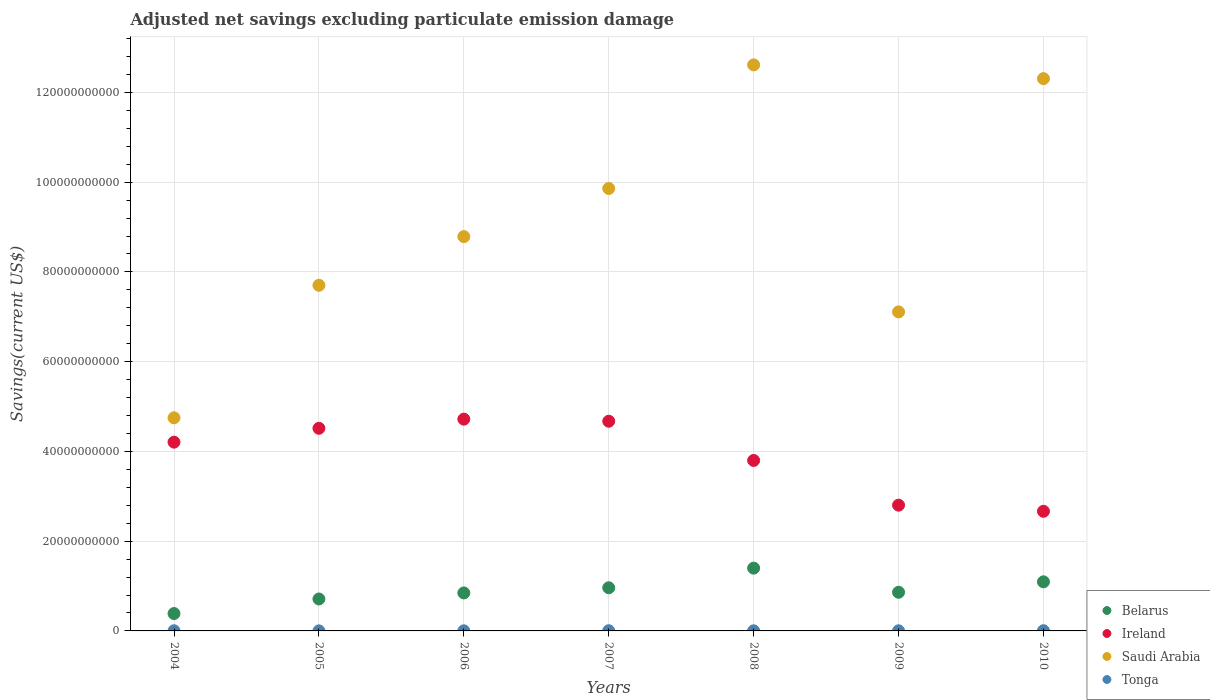What is the adjusted net savings in Saudi Arabia in 2007?
Your response must be concise. 9.86e+1. Across all years, what is the maximum adjusted net savings in Saudi Arabia?
Offer a very short reply. 1.26e+11. Across all years, what is the minimum adjusted net savings in Ireland?
Keep it short and to the point. 2.67e+1. What is the total adjusted net savings in Tonga in the graph?
Your answer should be very brief. 2.22e+08. What is the difference between the adjusted net savings in Belarus in 2008 and that in 2009?
Keep it short and to the point. 5.38e+09. What is the difference between the adjusted net savings in Ireland in 2006 and the adjusted net savings in Tonga in 2009?
Your answer should be compact. 4.72e+1. What is the average adjusted net savings in Saudi Arabia per year?
Offer a very short reply. 9.02e+1. In the year 2010, what is the difference between the adjusted net savings in Belarus and adjusted net savings in Ireland?
Offer a very short reply. -1.57e+1. What is the ratio of the adjusted net savings in Ireland in 2005 to that in 2009?
Ensure brevity in your answer.  1.61. Is the difference between the adjusted net savings in Belarus in 2006 and 2009 greater than the difference between the adjusted net savings in Ireland in 2006 and 2009?
Keep it short and to the point. No. What is the difference between the highest and the second highest adjusted net savings in Ireland?
Ensure brevity in your answer.  4.67e+08. What is the difference between the highest and the lowest adjusted net savings in Tonga?
Give a very brief answer. 3.14e+07. In how many years, is the adjusted net savings in Belarus greater than the average adjusted net savings in Belarus taken over all years?
Your response must be concise. 3. Is the sum of the adjusted net savings in Tonga in 2006 and 2007 greater than the maximum adjusted net savings in Belarus across all years?
Offer a very short reply. No. Is the adjusted net savings in Tonga strictly less than the adjusted net savings in Saudi Arabia over the years?
Make the answer very short. Yes. How many years are there in the graph?
Your response must be concise. 7. What is the difference between two consecutive major ticks on the Y-axis?
Your answer should be very brief. 2.00e+1. Does the graph contain any zero values?
Your answer should be very brief. No. Does the graph contain grids?
Offer a terse response. Yes. How many legend labels are there?
Your answer should be compact. 4. How are the legend labels stacked?
Make the answer very short. Vertical. What is the title of the graph?
Your answer should be compact. Adjusted net savings excluding particulate emission damage. Does "Malaysia" appear as one of the legend labels in the graph?
Provide a short and direct response. No. What is the label or title of the X-axis?
Give a very brief answer. Years. What is the label or title of the Y-axis?
Make the answer very short. Savings(current US$). What is the Savings(current US$) of Belarus in 2004?
Offer a very short reply. 3.87e+09. What is the Savings(current US$) in Ireland in 2004?
Offer a terse response. 4.21e+1. What is the Savings(current US$) of Saudi Arabia in 2004?
Give a very brief answer. 4.75e+1. What is the Savings(current US$) of Tonga in 2004?
Give a very brief answer. 3.54e+07. What is the Savings(current US$) of Belarus in 2005?
Keep it short and to the point. 7.12e+09. What is the Savings(current US$) of Ireland in 2005?
Provide a short and direct response. 4.52e+1. What is the Savings(current US$) in Saudi Arabia in 2005?
Offer a very short reply. 7.70e+1. What is the Savings(current US$) of Tonga in 2005?
Ensure brevity in your answer.  1.44e+07. What is the Savings(current US$) of Belarus in 2006?
Make the answer very short. 8.46e+09. What is the Savings(current US$) in Ireland in 2006?
Your answer should be compact. 4.72e+1. What is the Savings(current US$) in Saudi Arabia in 2006?
Offer a terse response. 8.79e+1. What is the Savings(current US$) in Tonga in 2006?
Offer a very short reply. 2.58e+07. What is the Savings(current US$) of Belarus in 2007?
Provide a short and direct response. 9.62e+09. What is the Savings(current US$) of Ireland in 2007?
Provide a succinct answer. 4.67e+1. What is the Savings(current US$) of Saudi Arabia in 2007?
Ensure brevity in your answer.  9.86e+1. What is the Savings(current US$) of Tonga in 2007?
Give a very brief answer. 4.41e+07. What is the Savings(current US$) of Belarus in 2008?
Provide a short and direct response. 1.40e+1. What is the Savings(current US$) in Ireland in 2008?
Give a very brief answer. 3.80e+1. What is the Savings(current US$) of Saudi Arabia in 2008?
Offer a terse response. 1.26e+11. What is the Savings(current US$) of Tonga in 2008?
Keep it short and to the point. 2.59e+07. What is the Savings(current US$) in Belarus in 2009?
Your response must be concise. 8.61e+09. What is the Savings(current US$) in Ireland in 2009?
Provide a short and direct response. 2.80e+1. What is the Savings(current US$) of Saudi Arabia in 2009?
Keep it short and to the point. 7.11e+1. What is the Savings(current US$) of Tonga in 2009?
Your answer should be very brief. 3.08e+07. What is the Savings(current US$) in Belarus in 2010?
Your answer should be compact. 1.09e+1. What is the Savings(current US$) of Ireland in 2010?
Ensure brevity in your answer.  2.67e+1. What is the Savings(current US$) in Saudi Arabia in 2010?
Ensure brevity in your answer.  1.23e+11. What is the Savings(current US$) of Tonga in 2010?
Offer a terse response. 4.58e+07. Across all years, what is the maximum Savings(current US$) of Belarus?
Give a very brief answer. 1.40e+1. Across all years, what is the maximum Savings(current US$) in Ireland?
Provide a succinct answer. 4.72e+1. Across all years, what is the maximum Savings(current US$) in Saudi Arabia?
Provide a short and direct response. 1.26e+11. Across all years, what is the maximum Savings(current US$) in Tonga?
Give a very brief answer. 4.58e+07. Across all years, what is the minimum Savings(current US$) in Belarus?
Offer a very short reply. 3.87e+09. Across all years, what is the minimum Savings(current US$) of Ireland?
Ensure brevity in your answer.  2.67e+1. Across all years, what is the minimum Savings(current US$) in Saudi Arabia?
Your answer should be very brief. 4.75e+1. Across all years, what is the minimum Savings(current US$) in Tonga?
Your response must be concise. 1.44e+07. What is the total Savings(current US$) of Belarus in the graph?
Ensure brevity in your answer.  6.26e+1. What is the total Savings(current US$) of Ireland in the graph?
Your answer should be very brief. 2.74e+11. What is the total Savings(current US$) of Saudi Arabia in the graph?
Offer a very short reply. 6.31e+11. What is the total Savings(current US$) in Tonga in the graph?
Your answer should be compact. 2.22e+08. What is the difference between the Savings(current US$) in Belarus in 2004 and that in 2005?
Provide a succinct answer. -3.24e+09. What is the difference between the Savings(current US$) of Ireland in 2004 and that in 2005?
Offer a terse response. -3.09e+09. What is the difference between the Savings(current US$) in Saudi Arabia in 2004 and that in 2005?
Offer a terse response. -2.95e+1. What is the difference between the Savings(current US$) of Tonga in 2004 and that in 2005?
Keep it short and to the point. 2.10e+07. What is the difference between the Savings(current US$) of Belarus in 2004 and that in 2006?
Give a very brief answer. -4.59e+09. What is the difference between the Savings(current US$) in Ireland in 2004 and that in 2006?
Your answer should be compact. -5.13e+09. What is the difference between the Savings(current US$) of Saudi Arabia in 2004 and that in 2006?
Your answer should be very brief. -4.04e+1. What is the difference between the Savings(current US$) of Tonga in 2004 and that in 2006?
Your response must be concise. 9.57e+06. What is the difference between the Savings(current US$) of Belarus in 2004 and that in 2007?
Offer a terse response. -5.74e+09. What is the difference between the Savings(current US$) in Ireland in 2004 and that in 2007?
Your response must be concise. -4.66e+09. What is the difference between the Savings(current US$) of Saudi Arabia in 2004 and that in 2007?
Keep it short and to the point. -5.11e+1. What is the difference between the Savings(current US$) of Tonga in 2004 and that in 2007?
Keep it short and to the point. -8.75e+06. What is the difference between the Savings(current US$) in Belarus in 2004 and that in 2008?
Your answer should be very brief. -1.01e+1. What is the difference between the Savings(current US$) of Ireland in 2004 and that in 2008?
Keep it short and to the point. 4.07e+09. What is the difference between the Savings(current US$) of Saudi Arabia in 2004 and that in 2008?
Your answer should be compact. -7.86e+1. What is the difference between the Savings(current US$) of Tonga in 2004 and that in 2008?
Make the answer very short. 9.45e+06. What is the difference between the Savings(current US$) in Belarus in 2004 and that in 2009?
Offer a terse response. -4.74e+09. What is the difference between the Savings(current US$) in Ireland in 2004 and that in 2009?
Your answer should be compact. 1.40e+1. What is the difference between the Savings(current US$) in Saudi Arabia in 2004 and that in 2009?
Ensure brevity in your answer.  -2.36e+1. What is the difference between the Savings(current US$) of Tonga in 2004 and that in 2009?
Provide a succinct answer. 4.51e+06. What is the difference between the Savings(current US$) in Belarus in 2004 and that in 2010?
Make the answer very short. -7.07e+09. What is the difference between the Savings(current US$) of Ireland in 2004 and that in 2010?
Make the answer very short. 1.54e+1. What is the difference between the Savings(current US$) in Saudi Arabia in 2004 and that in 2010?
Your answer should be compact. -7.56e+1. What is the difference between the Savings(current US$) in Tonga in 2004 and that in 2010?
Make the answer very short. -1.04e+07. What is the difference between the Savings(current US$) of Belarus in 2005 and that in 2006?
Keep it short and to the point. -1.35e+09. What is the difference between the Savings(current US$) in Ireland in 2005 and that in 2006?
Your answer should be compact. -2.04e+09. What is the difference between the Savings(current US$) of Saudi Arabia in 2005 and that in 2006?
Offer a very short reply. -1.08e+1. What is the difference between the Savings(current US$) of Tonga in 2005 and that in 2006?
Provide a succinct answer. -1.14e+07. What is the difference between the Savings(current US$) in Belarus in 2005 and that in 2007?
Ensure brevity in your answer.  -2.50e+09. What is the difference between the Savings(current US$) of Ireland in 2005 and that in 2007?
Keep it short and to the point. -1.57e+09. What is the difference between the Savings(current US$) in Saudi Arabia in 2005 and that in 2007?
Offer a terse response. -2.16e+1. What is the difference between the Savings(current US$) of Tonga in 2005 and that in 2007?
Keep it short and to the point. -2.97e+07. What is the difference between the Savings(current US$) of Belarus in 2005 and that in 2008?
Your answer should be compact. -6.87e+09. What is the difference between the Savings(current US$) of Ireland in 2005 and that in 2008?
Your answer should be compact. 7.16e+09. What is the difference between the Savings(current US$) in Saudi Arabia in 2005 and that in 2008?
Provide a short and direct response. -4.91e+1. What is the difference between the Savings(current US$) of Tonga in 2005 and that in 2008?
Make the answer very short. -1.15e+07. What is the difference between the Savings(current US$) of Belarus in 2005 and that in 2009?
Your answer should be very brief. -1.50e+09. What is the difference between the Savings(current US$) in Ireland in 2005 and that in 2009?
Provide a short and direct response. 1.71e+1. What is the difference between the Savings(current US$) of Saudi Arabia in 2005 and that in 2009?
Offer a terse response. 5.93e+09. What is the difference between the Savings(current US$) in Tonga in 2005 and that in 2009?
Make the answer very short. -1.65e+07. What is the difference between the Savings(current US$) in Belarus in 2005 and that in 2010?
Give a very brief answer. -3.82e+09. What is the difference between the Savings(current US$) of Ireland in 2005 and that in 2010?
Your answer should be very brief. 1.85e+1. What is the difference between the Savings(current US$) of Saudi Arabia in 2005 and that in 2010?
Give a very brief answer. -4.61e+1. What is the difference between the Savings(current US$) in Tonga in 2005 and that in 2010?
Your response must be concise. -3.14e+07. What is the difference between the Savings(current US$) in Belarus in 2006 and that in 2007?
Your response must be concise. -1.15e+09. What is the difference between the Savings(current US$) in Ireland in 2006 and that in 2007?
Your answer should be compact. 4.67e+08. What is the difference between the Savings(current US$) of Saudi Arabia in 2006 and that in 2007?
Your answer should be compact. -1.07e+1. What is the difference between the Savings(current US$) of Tonga in 2006 and that in 2007?
Your answer should be compact. -1.83e+07. What is the difference between the Savings(current US$) in Belarus in 2006 and that in 2008?
Your response must be concise. -5.53e+09. What is the difference between the Savings(current US$) in Ireland in 2006 and that in 2008?
Offer a very short reply. 9.20e+09. What is the difference between the Savings(current US$) of Saudi Arabia in 2006 and that in 2008?
Ensure brevity in your answer.  -3.83e+1. What is the difference between the Savings(current US$) of Tonga in 2006 and that in 2008?
Offer a very short reply. -1.22e+05. What is the difference between the Savings(current US$) in Belarus in 2006 and that in 2009?
Offer a terse response. -1.50e+08. What is the difference between the Savings(current US$) of Ireland in 2006 and that in 2009?
Ensure brevity in your answer.  1.92e+1. What is the difference between the Savings(current US$) of Saudi Arabia in 2006 and that in 2009?
Provide a short and direct response. 1.68e+1. What is the difference between the Savings(current US$) in Tonga in 2006 and that in 2009?
Ensure brevity in your answer.  -5.06e+06. What is the difference between the Savings(current US$) in Belarus in 2006 and that in 2010?
Your response must be concise. -2.48e+09. What is the difference between the Savings(current US$) in Ireland in 2006 and that in 2010?
Provide a succinct answer. 2.05e+1. What is the difference between the Savings(current US$) of Saudi Arabia in 2006 and that in 2010?
Your answer should be compact. -3.52e+1. What is the difference between the Savings(current US$) of Tonga in 2006 and that in 2010?
Make the answer very short. -2.00e+07. What is the difference between the Savings(current US$) of Belarus in 2007 and that in 2008?
Provide a succinct answer. -4.37e+09. What is the difference between the Savings(current US$) of Ireland in 2007 and that in 2008?
Your answer should be compact. 8.74e+09. What is the difference between the Savings(current US$) in Saudi Arabia in 2007 and that in 2008?
Your answer should be very brief. -2.75e+1. What is the difference between the Savings(current US$) of Tonga in 2007 and that in 2008?
Provide a short and direct response. 1.82e+07. What is the difference between the Savings(current US$) of Belarus in 2007 and that in 2009?
Provide a succinct answer. 1.00e+09. What is the difference between the Savings(current US$) in Ireland in 2007 and that in 2009?
Your response must be concise. 1.87e+1. What is the difference between the Savings(current US$) of Saudi Arabia in 2007 and that in 2009?
Offer a terse response. 2.75e+1. What is the difference between the Savings(current US$) in Tonga in 2007 and that in 2009?
Offer a terse response. 1.33e+07. What is the difference between the Savings(current US$) in Belarus in 2007 and that in 2010?
Give a very brief answer. -1.32e+09. What is the difference between the Savings(current US$) of Ireland in 2007 and that in 2010?
Offer a very short reply. 2.01e+1. What is the difference between the Savings(current US$) of Saudi Arabia in 2007 and that in 2010?
Offer a very short reply. -2.45e+1. What is the difference between the Savings(current US$) in Tonga in 2007 and that in 2010?
Give a very brief answer. -1.69e+06. What is the difference between the Savings(current US$) of Belarus in 2008 and that in 2009?
Ensure brevity in your answer.  5.38e+09. What is the difference between the Savings(current US$) of Ireland in 2008 and that in 2009?
Offer a very short reply. 9.96e+09. What is the difference between the Savings(current US$) in Saudi Arabia in 2008 and that in 2009?
Offer a very short reply. 5.50e+1. What is the difference between the Savings(current US$) in Tonga in 2008 and that in 2009?
Give a very brief answer. -4.94e+06. What is the difference between the Savings(current US$) in Belarus in 2008 and that in 2010?
Keep it short and to the point. 3.05e+09. What is the difference between the Savings(current US$) of Ireland in 2008 and that in 2010?
Your response must be concise. 1.13e+1. What is the difference between the Savings(current US$) of Saudi Arabia in 2008 and that in 2010?
Offer a terse response. 3.06e+09. What is the difference between the Savings(current US$) in Tonga in 2008 and that in 2010?
Offer a terse response. -1.99e+07. What is the difference between the Savings(current US$) in Belarus in 2009 and that in 2010?
Make the answer very short. -2.33e+09. What is the difference between the Savings(current US$) in Ireland in 2009 and that in 2010?
Provide a short and direct response. 1.36e+09. What is the difference between the Savings(current US$) in Saudi Arabia in 2009 and that in 2010?
Your response must be concise. -5.20e+1. What is the difference between the Savings(current US$) in Tonga in 2009 and that in 2010?
Give a very brief answer. -1.49e+07. What is the difference between the Savings(current US$) of Belarus in 2004 and the Savings(current US$) of Ireland in 2005?
Offer a very short reply. -4.13e+1. What is the difference between the Savings(current US$) of Belarus in 2004 and the Savings(current US$) of Saudi Arabia in 2005?
Give a very brief answer. -7.31e+1. What is the difference between the Savings(current US$) of Belarus in 2004 and the Savings(current US$) of Tonga in 2005?
Make the answer very short. 3.86e+09. What is the difference between the Savings(current US$) of Ireland in 2004 and the Savings(current US$) of Saudi Arabia in 2005?
Make the answer very short. -3.50e+1. What is the difference between the Savings(current US$) in Ireland in 2004 and the Savings(current US$) in Tonga in 2005?
Provide a short and direct response. 4.20e+1. What is the difference between the Savings(current US$) of Saudi Arabia in 2004 and the Savings(current US$) of Tonga in 2005?
Make the answer very short. 4.75e+1. What is the difference between the Savings(current US$) in Belarus in 2004 and the Savings(current US$) in Ireland in 2006?
Give a very brief answer. -4.33e+1. What is the difference between the Savings(current US$) of Belarus in 2004 and the Savings(current US$) of Saudi Arabia in 2006?
Offer a very short reply. -8.40e+1. What is the difference between the Savings(current US$) in Belarus in 2004 and the Savings(current US$) in Tonga in 2006?
Offer a terse response. 3.85e+09. What is the difference between the Savings(current US$) in Ireland in 2004 and the Savings(current US$) in Saudi Arabia in 2006?
Give a very brief answer. -4.58e+1. What is the difference between the Savings(current US$) of Ireland in 2004 and the Savings(current US$) of Tonga in 2006?
Keep it short and to the point. 4.20e+1. What is the difference between the Savings(current US$) of Saudi Arabia in 2004 and the Savings(current US$) of Tonga in 2006?
Your response must be concise. 4.75e+1. What is the difference between the Savings(current US$) of Belarus in 2004 and the Savings(current US$) of Ireland in 2007?
Your answer should be compact. -4.28e+1. What is the difference between the Savings(current US$) in Belarus in 2004 and the Savings(current US$) in Saudi Arabia in 2007?
Your answer should be compact. -9.47e+1. What is the difference between the Savings(current US$) of Belarus in 2004 and the Savings(current US$) of Tonga in 2007?
Give a very brief answer. 3.83e+09. What is the difference between the Savings(current US$) of Ireland in 2004 and the Savings(current US$) of Saudi Arabia in 2007?
Your response must be concise. -5.65e+1. What is the difference between the Savings(current US$) of Ireland in 2004 and the Savings(current US$) of Tonga in 2007?
Offer a terse response. 4.20e+1. What is the difference between the Savings(current US$) in Saudi Arabia in 2004 and the Savings(current US$) in Tonga in 2007?
Make the answer very short. 4.74e+1. What is the difference between the Savings(current US$) in Belarus in 2004 and the Savings(current US$) in Ireland in 2008?
Make the answer very short. -3.41e+1. What is the difference between the Savings(current US$) of Belarus in 2004 and the Savings(current US$) of Saudi Arabia in 2008?
Your response must be concise. -1.22e+11. What is the difference between the Savings(current US$) in Belarus in 2004 and the Savings(current US$) in Tonga in 2008?
Offer a terse response. 3.85e+09. What is the difference between the Savings(current US$) in Ireland in 2004 and the Savings(current US$) in Saudi Arabia in 2008?
Keep it short and to the point. -8.41e+1. What is the difference between the Savings(current US$) of Ireland in 2004 and the Savings(current US$) of Tonga in 2008?
Ensure brevity in your answer.  4.20e+1. What is the difference between the Savings(current US$) of Saudi Arabia in 2004 and the Savings(current US$) of Tonga in 2008?
Ensure brevity in your answer.  4.75e+1. What is the difference between the Savings(current US$) of Belarus in 2004 and the Savings(current US$) of Ireland in 2009?
Provide a succinct answer. -2.41e+1. What is the difference between the Savings(current US$) of Belarus in 2004 and the Savings(current US$) of Saudi Arabia in 2009?
Offer a very short reply. -6.72e+1. What is the difference between the Savings(current US$) of Belarus in 2004 and the Savings(current US$) of Tonga in 2009?
Make the answer very short. 3.84e+09. What is the difference between the Savings(current US$) in Ireland in 2004 and the Savings(current US$) in Saudi Arabia in 2009?
Give a very brief answer. -2.90e+1. What is the difference between the Savings(current US$) in Ireland in 2004 and the Savings(current US$) in Tonga in 2009?
Give a very brief answer. 4.20e+1. What is the difference between the Savings(current US$) in Saudi Arabia in 2004 and the Savings(current US$) in Tonga in 2009?
Make the answer very short. 4.75e+1. What is the difference between the Savings(current US$) of Belarus in 2004 and the Savings(current US$) of Ireland in 2010?
Ensure brevity in your answer.  -2.28e+1. What is the difference between the Savings(current US$) in Belarus in 2004 and the Savings(current US$) in Saudi Arabia in 2010?
Your answer should be compact. -1.19e+11. What is the difference between the Savings(current US$) of Belarus in 2004 and the Savings(current US$) of Tonga in 2010?
Provide a short and direct response. 3.83e+09. What is the difference between the Savings(current US$) in Ireland in 2004 and the Savings(current US$) in Saudi Arabia in 2010?
Keep it short and to the point. -8.10e+1. What is the difference between the Savings(current US$) of Ireland in 2004 and the Savings(current US$) of Tonga in 2010?
Offer a very short reply. 4.20e+1. What is the difference between the Savings(current US$) in Saudi Arabia in 2004 and the Savings(current US$) in Tonga in 2010?
Offer a terse response. 4.74e+1. What is the difference between the Savings(current US$) in Belarus in 2005 and the Savings(current US$) in Ireland in 2006?
Ensure brevity in your answer.  -4.01e+1. What is the difference between the Savings(current US$) of Belarus in 2005 and the Savings(current US$) of Saudi Arabia in 2006?
Offer a terse response. -8.07e+1. What is the difference between the Savings(current US$) of Belarus in 2005 and the Savings(current US$) of Tonga in 2006?
Ensure brevity in your answer.  7.09e+09. What is the difference between the Savings(current US$) in Ireland in 2005 and the Savings(current US$) in Saudi Arabia in 2006?
Your answer should be very brief. -4.27e+1. What is the difference between the Savings(current US$) in Ireland in 2005 and the Savings(current US$) in Tonga in 2006?
Offer a very short reply. 4.51e+1. What is the difference between the Savings(current US$) in Saudi Arabia in 2005 and the Savings(current US$) in Tonga in 2006?
Provide a short and direct response. 7.70e+1. What is the difference between the Savings(current US$) of Belarus in 2005 and the Savings(current US$) of Ireland in 2007?
Provide a succinct answer. -3.96e+1. What is the difference between the Savings(current US$) in Belarus in 2005 and the Savings(current US$) in Saudi Arabia in 2007?
Ensure brevity in your answer.  -9.15e+1. What is the difference between the Savings(current US$) of Belarus in 2005 and the Savings(current US$) of Tonga in 2007?
Make the answer very short. 7.07e+09. What is the difference between the Savings(current US$) of Ireland in 2005 and the Savings(current US$) of Saudi Arabia in 2007?
Your answer should be very brief. -5.34e+1. What is the difference between the Savings(current US$) in Ireland in 2005 and the Savings(current US$) in Tonga in 2007?
Provide a succinct answer. 4.51e+1. What is the difference between the Savings(current US$) in Saudi Arabia in 2005 and the Savings(current US$) in Tonga in 2007?
Your answer should be very brief. 7.70e+1. What is the difference between the Savings(current US$) of Belarus in 2005 and the Savings(current US$) of Ireland in 2008?
Make the answer very short. -3.09e+1. What is the difference between the Savings(current US$) of Belarus in 2005 and the Savings(current US$) of Saudi Arabia in 2008?
Provide a short and direct response. -1.19e+11. What is the difference between the Savings(current US$) of Belarus in 2005 and the Savings(current US$) of Tonga in 2008?
Make the answer very short. 7.09e+09. What is the difference between the Savings(current US$) in Ireland in 2005 and the Savings(current US$) in Saudi Arabia in 2008?
Your answer should be very brief. -8.10e+1. What is the difference between the Savings(current US$) of Ireland in 2005 and the Savings(current US$) of Tonga in 2008?
Your answer should be very brief. 4.51e+1. What is the difference between the Savings(current US$) in Saudi Arabia in 2005 and the Savings(current US$) in Tonga in 2008?
Ensure brevity in your answer.  7.70e+1. What is the difference between the Savings(current US$) of Belarus in 2005 and the Savings(current US$) of Ireland in 2009?
Give a very brief answer. -2.09e+1. What is the difference between the Savings(current US$) of Belarus in 2005 and the Savings(current US$) of Saudi Arabia in 2009?
Offer a terse response. -6.40e+1. What is the difference between the Savings(current US$) of Belarus in 2005 and the Savings(current US$) of Tonga in 2009?
Offer a terse response. 7.09e+09. What is the difference between the Savings(current US$) in Ireland in 2005 and the Savings(current US$) in Saudi Arabia in 2009?
Your answer should be compact. -2.59e+1. What is the difference between the Savings(current US$) in Ireland in 2005 and the Savings(current US$) in Tonga in 2009?
Your answer should be very brief. 4.51e+1. What is the difference between the Savings(current US$) in Saudi Arabia in 2005 and the Savings(current US$) in Tonga in 2009?
Your answer should be very brief. 7.70e+1. What is the difference between the Savings(current US$) of Belarus in 2005 and the Savings(current US$) of Ireland in 2010?
Offer a very short reply. -1.95e+1. What is the difference between the Savings(current US$) in Belarus in 2005 and the Savings(current US$) in Saudi Arabia in 2010?
Your response must be concise. -1.16e+11. What is the difference between the Savings(current US$) in Belarus in 2005 and the Savings(current US$) in Tonga in 2010?
Provide a succinct answer. 7.07e+09. What is the difference between the Savings(current US$) in Ireland in 2005 and the Savings(current US$) in Saudi Arabia in 2010?
Your answer should be very brief. -7.79e+1. What is the difference between the Savings(current US$) in Ireland in 2005 and the Savings(current US$) in Tonga in 2010?
Offer a terse response. 4.51e+1. What is the difference between the Savings(current US$) of Saudi Arabia in 2005 and the Savings(current US$) of Tonga in 2010?
Give a very brief answer. 7.70e+1. What is the difference between the Savings(current US$) in Belarus in 2006 and the Savings(current US$) in Ireland in 2007?
Your response must be concise. -3.83e+1. What is the difference between the Savings(current US$) of Belarus in 2006 and the Savings(current US$) of Saudi Arabia in 2007?
Give a very brief answer. -9.01e+1. What is the difference between the Savings(current US$) in Belarus in 2006 and the Savings(current US$) in Tonga in 2007?
Give a very brief answer. 8.42e+09. What is the difference between the Savings(current US$) in Ireland in 2006 and the Savings(current US$) in Saudi Arabia in 2007?
Make the answer very short. -5.14e+1. What is the difference between the Savings(current US$) of Ireland in 2006 and the Savings(current US$) of Tonga in 2007?
Keep it short and to the point. 4.71e+1. What is the difference between the Savings(current US$) in Saudi Arabia in 2006 and the Savings(current US$) in Tonga in 2007?
Offer a terse response. 8.78e+1. What is the difference between the Savings(current US$) of Belarus in 2006 and the Savings(current US$) of Ireland in 2008?
Give a very brief answer. -2.95e+1. What is the difference between the Savings(current US$) of Belarus in 2006 and the Savings(current US$) of Saudi Arabia in 2008?
Your answer should be very brief. -1.18e+11. What is the difference between the Savings(current US$) in Belarus in 2006 and the Savings(current US$) in Tonga in 2008?
Make the answer very short. 8.44e+09. What is the difference between the Savings(current US$) in Ireland in 2006 and the Savings(current US$) in Saudi Arabia in 2008?
Make the answer very short. -7.89e+1. What is the difference between the Savings(current US$) in Ireland in 2006 and the Savings(current US$) in Tonga in 2008?
Provide a short and direct response. 4.72e+1. What is the difference between the Savings(current US$) of Saudi Arabia in 2006 and the Savings(current US$) of Tonga in 2008?
Provide a succinct answer. 8.78e+1. What is the difference between the Savings(current US$) of Belarus in 2006 and the Savings(current US$) of Ireland in 2009?
Offer a very short reply. -1.96e+1. What is the difference between the Savings(current US$) in Belarus in 2006 and the Savings(current US$) in Saudi Arabia in 2009?
Make the answer very short. -6.26e+1. What is the difference between the Savings(current US$) in Belarus in 2006 and the Savings(current US$) in Tonga in 2009?
Ensure brevity in your answer.  8.43e+09. What is the difference between the Savings(current US$) in Ireland in 2006 and the Savings(current US$) in Saudi Arabia in 2009?
Offer a terse response. -2.39e+1. What is the difference between the Savings(current US$) in Ireland in 2006 and the Savings(current US$) in Tonga in 2009?
Give a very brief answer. 4.72e+1. What is the difference between the Savings(current US$) in Saudi Arabia in 2006 and the Savings(current US$) in Tonga in 2009?
Provide a succinct answer. 8.78e+1. What is the difference between the Savings(current US$) of Belarus in 2006 and the Savings(current US$) of Ireland in 2010?
Ensure brevity in your answer.  -1.82e+1. What is the difference between the Savings(current US$) in Belarus in 2006 and the Savings(current US$) in Saudi Arabia in 2010?
Give a very brief answer. -1.15e+11. What is the difference between the Savings(current US$) of Belarus in 2006 and the Savings(current US$) of Tonga in 2010?
Offer a very short reply. 8.42e+09. What is the difference between the Savings(current US$) in Ireland in 2006 and the Savings(current US$) in Saudi Arabia in 2010?
Offer a terse response. -7.59e+1. What is the difference between the Savings(current US$) of Ireland in 2006 and the Savings(current US$) of Tonga in 2010?
Provide a short and direct response. 4.71e+1. What is the difference between the Savings(current US$) in Saudi Arabia in 2006 and the Savings(current US$) in Tonga in 2010?
Offer a very short reply. 8.78e+1. What is the difference between the Savings(current US$) in Belarus in 2007 and the Savings(current US$) in Ireland in 2008?
Make the answer very short. -2.84e+1. What is the difference between the Savings(current US$) in Belarus in 2007 and the Savings(current US$) in Saudi Arabia in 2008?
Make the answer very short. -1.17e+11. What is the difference between the Savings(current US$) in Belarus in 2007 and the Savings(current US$) in Tonga in 2008?
Ensure brevity in your answer.  9.59e+09. What is the difference between the Savings(current US$) of Ireland in 2007 and the Savings(current US$) of Saudi Arabia in 2008?
Keep it short and to the point. -7.94e+1. What is the difference between the Savings(current US$) in Ireland in 2007 and the Savings(current US$) in Tonga in 2008?
Give a very brief answer. 4.67e+1. What is the difference between the Savings(current US$) of Saudi Arabia in 2007 and the Savings(current US$) of Tonga in 2008?
Offer a terse response. 9.86e+1. What is the difference between the Savings(current US$) in Belarus in 2007 and the Savings(current US$) in Ireland in 2009?
Give a very brief answer. -1.84e+1. What is the difference between the Savings(current US$) of Belarus in 2007 and the Savings(current US$) of Saudi Arabia in 2009?
Your answer should be compact. -6.15e+1. What is the difference between the Savings(current US$) of Belarus in 2007 and the Savings(current US$) of Tonga in 2009?
Make the answer very short. 9.59e+09. What is the difference between the Savings(current US$) in Ireland in 2007 and the Savings(current US$) in Saudi Arabia in 2009?
Offer a terse response. -2.44e+1. What is the difference between the Savings(current US$) in Ireland in 2007 and the Savings(current US$) in Tonga in 2009?
Provide a succinct answer. 4.67e+1. What is the difference between the Savings(current US$) in Saudi Arabia in 2007 and the Savings(current US$) in Tonga in 2009?
Give a very brief answer. 9.86e+1. What is the difference between the Savings(current US$) in Belarus in 2007 and the Savings(current US$) in Ireland in 2010?
Your answer should be compact. -1.70e+1. What is the difference between the Savings(current US$) of Belarus in 2007 and the Savings(current US$) of Saudi Arabia in 2010?
Your response must be concise. -1.13e+11. What is the difference between the Savings(current US$) in Belarus in 2007 and the Savings(current US$) in Tonga in 2010?
Offer a terse response. 9.57e+09. What is the difference between the Savings(current US$) of Ireland in 2007 and the Savings(current US$) of Saudi Arabia in 2010?
Keep it short and to the point. -7.63e+1. What is the difference between the Savings(current US$) in Ireland in 2007 and the Savings(current US$) in Tonga in 2010?
Keep it short and to the point. 4.67e+1. What is the difference between the Savings(current US$) of Saudi Arabia in 2007 and the Savings(current US$) of Tonga in 2010?
Offer a terse response. 9.85e+1. What is the difference between the Savings(current US$) in Belarus in 2008 and the Savings(current US$) in Ireland in 2009?
Your response must be concise. -1.40e+1. What is the difference between the Savings(current US$) of Belarus in 2008 and the Savings(current US$) of Saudi Arabia in 2009?
Provide a short and direct response. -5.71e+1. What is the difference between the Savings(current US$) of Belarus in 2008 and the Savings(current US$) of Tonga in 2009?
Provide a short and direct response. 1.40e+1. What is the difference between the Savings(current US$) in Ireland in 2008 and the Savings(current US$) in Saudi Arabia in 2009?
Ensure brevity in your answer.  -3.31e+1. What is the difference between the Savings(current US$) in Ireland in 2008 and the Savings(current US$) in Tonga in 2009?
Offer a terse response. 3.80e+1. What is the difference between the Savings(current US$) of Saudi Arabia in 2008 and the Savings(current US$) of Tonga in 2009?
Give a very brief answer. 1.26e+11. What is the difference between the Savings(current US$) in Belarus in 2008 and the Savings(current US$) in Ireland in 2010?
Ensure brevity in your answer.  -1.27e+1. What is the difference between the Savings(current US$) of Belarus in 2008 and the Savings(current US$) of Saudi Arabia in 2010?
Keep it short and to the point. -1.09e+11. What is the difference between the Savings(current US$) of Belarus in 2008 and the Savings(current US$) of Tonga in 2010?
Make the answer very short. 1.39e+1. What is the difference between the Savings(current US$) of Ireland in 2008 and the Savings(current US$) of Saudi Arabia in 2010?
Your response must be concise. -8.51e+1. What is the difference between the Savings(current US$) of Ireland in 2008 and the Savings(current US$) of Tonga in 2010?
Your response must be concise. 3.79e+1. What is the difference between the Savings(current US$) of Saudi Arabia in 2008 and the Savings(current US$) of Tonga in 2010?
Give a very brief answer. 1.26e+11. What is the difference between the Savings(current US$) of Belarus in 2009 and the Savings(current US$) of Ireland in 2010?
Provide a succinct answer. -1.80e+1. What is the difference between the Savings(current US$) of Belarus in 2009 and the Savings(current US$) of Saudi Arabia in 2010?
Offer a terse response. -1.14e+11. What is the difference between the Savings(current US$) of Belarus in 2009 and the Savings(current US$) of Tonga in 2010?
Keep it short and to the point. 8.57e+09. What is the difference between the Savings(current US$) of Ireland in 2009 and the Savings(current US$) of Saudi Arabia in 2010?
Make the answer very short. -9.50e+1. What is the difference between the Savings(current US$) in Ireland in 2009 and the Savings(current US$) in Tonga in 2010?
Offer a terse response. 2.80e+1. What is the difference between the Savings(current US$) in Saudi Arabia in 2009 and the Savings(current US$) in Tonga in 2010?
Ensure brevity in your answer.  7.10e+1. What is the average Savings(current US$) of Belarus per year?
Ensure brevity in your answer.  8.95e+09. What is the average Savings(current US$) in Ireland per year?
Offer a very short reply. 3.91e+1. What is the average Savings(current US$) of Saudi Arabia per year?
Your response must be concise. 9.02e+1. What is the average Savings(current US$) of Tonga per year?
Your response must be concise. 3.17e+07. In the year 2004, what is the difference between the Savings(current US$) in Belarus and Savings(current US$) in Ireland?
Your answer should be very brief. -3.82e+1. In the year 2004, what is the difference between the Savings(current US$) in Belarus and Savings(current US$) in Saudi Arabia?
Your response must be concise. -4.36e+1. In the year 2004, what is the difference between the Savings(current US$) in Belarus and Savings(current US$) in Tonga?
Offer a very short reply. 3.84e+09. In the year 2004, what is the difference between the Savings(current US$) in Ireland and Savings(current US$) in Saudi Arabia?
Your response must be concise. -5.43e+09. In the year 2004, what is the difference between the Savings(current US$) of Ireland and Savings(current US$) of Tonga?
Your answer should be very brief. 4.20e+1. In the year 2004, what is the difference between the Savings(current US$) of Saudi Arabia and Savings(current US$) of Tonga?
Provide a short and direct response. 4.75e+1. In the year 2005, what is the difference between the Savings(current US$) of Belarus and Savings(current US$) of Ireland?
Make the answer very short. -3.80e+1. In the year 2005, what is the difference between the Savings(current US$) of Belarus and Savings(current US$) of Saudi Arabia?
Provide a succinct answer. -6.99e+1. In the year 2005, what is the difference between the Savings(current US$) in Belarus and Savings(current US$) in Tonga?
Ensure brevity in your answer.  7.10e+09. In the year 2005, what is the difference between the Savings(current US$) of Ireland and Savings(current US$) of Saudi Arabia?
Offer a terse response. -3.19e+1. In the year 2005, what is the difference between the Savings(current US$) of Ireland and Savings(current US$) of Tonga?
Offer a terse response. 4.51e+1. In the year 2005, what is the difference between the Savings(current US$) of Saudi Arabia and Savings(current US$) of Tonga?
Your response must be concise. 7.70e+1. In the year 2006, what is the difference between the Savings(current US$) in Belarus and Savings(current US$) in Ireland?
Provide a short and direct response. -3.87e+1. In the year 2006, what is the difference between the Savings(current US$) of Belarus and Savings(current US$) of Saudi Arabia?
Offer a very short reply. -7.94e+1. In the year 2006, what is the difference between the Savings(current US$) of Belarus and Savings(current US$) of Tonga?
Your answer should be compact. 8.44e+09. In the year 2006, what is the difference between the Savings(current US$) in Ireland and Savings(current US$) in Saudi Arabia?
Your response must be concise. -4.07e+1. In the year 2006, what is the difference between the Savings(current US$) of Ireland and Savings(current US$) of Tonga?
Your answer should be compact. 4.72e+1. In the year 2006, what is the difference between the Savings(current US$) in Saudi Arabia and Savings(current US$) in Tonga?
Give a very brief answer. 8.78e+1. In the year 2007, what is the difference between the Savings(current US$) in Belarus and Savings(current US$) in Ireland?
Give a very brief answer. -3.71e+1. In the year 2007, what is the difference between the Savings(current US$) of Belarus and Savings(current US$) of Saudi Arabia?
Your answer should be very brief. -8.90e+1. In the year 2007, what is the difference between the Savings(current US$) in Belarus and Savings(current US$) in Tonga?
Your answer should be very brief. 9.57e+09. In the year 2007, what is the difference between the Savings(current US$) of Ireland and Savings(current US$) of Saudi Arabia?
Ensure brevity in your answer.  -5.19e+1. In the year 2007, what is the difference between the Savings(current US$) in Ireland and Savings(current US$) in Tonga?
Make the answer very short. 4.67e+1. In the year 2007, what is the difference between the Savings(current US$) in Saudi Arabia and Savings(current US$) in Tonga?
Your response must be concise. 9.85e+1. In the year 2008, what is the difference between the Savings(current US$) in Belarus and Savings(current US$) in Ireland?
Provide a short and direct response. -2.40e+1. In the year 2008, what is the difference between the Savings(current US$) of Belarus and Savings(current US$) of Saudi Arabia?
Keep it short and to the point. -1.12e+11. In the year 2008, what is the difference between the Savings(current US$) in Belarus and Savings(current US$) in Tonga?
Make the answer very short. 1.40e+1. In the year 2008, what is the difference between the Savings(current US$) in Ireland and Savings(current US$) in Saudi Arabia?
Provide a short and direct response. -8.81e+1. In the year 2008, what is the difference between the Savings(current US$) in Ireland and Savings(current US$) in Tonga?
Provide a short and direct response. 3.80e+1. In the year 2008, what is the difference between the Savings(current US$) in Saudi Arabia and Savings(current US$) in Tonga?
Make the answer very short. 1.26e+11. In the year 2009, what is the difference between the Savings(current US$) of Belarus and Savings(current US$) of Ireland?
Your response must be concise. -1.94e+1. In the year 2009, what is the difference between the Savings(current US$) in Belarus and Savings(current US$) in Saudi Arabia?
Give a very brief answer. -6.25e+1. In the year 2009, what is the difference between the Savings(current US$) in Belarus and Savings(current US$) in Tonga?
Offer a very short reply. 8.58e+09. In the year 2009, what is the difference between the Savings(current US$) of Ireland and Savings(current US$) of Saudi Arabia?
Your response must be concise. -4.31e+1. In the year 2009, what is the difference between the Savings(current US$) of Ireland and Savings(current US$) of Tonga?
Keep it short and to the point. 2.80e+1. In the year 2009, what is the difference between the Savings(current US$) in Saudi Arabia and Savings(current US$) in Tonga?
Provide a short and direct response. 7.11e+1. In the year 2010, what is the difference between the Savings(current US$) in Belarus and Savings(current US$) in Ireland?
Give a very brief answer. -1.57e+1. In the year 2010, what is the difference between the Savings(current US$) in Belarus and Savings(current US$) in Saudi Arabia?
Your response must be concise. -1.12e+11. In the year 2010, what is the difference between the Savings(current US$) of Belarus and Savings(current US$) of Tonga?
Provide a succinct answer. 1.09e+1. In the year 2010, what is the difference between the Savings(current US$) of Ireland and Savings(current US$) of Saudi Arabia?
Offer a very short reply. -9.64e+1. In the year 2010, what is the difference between the Savings(current US$) of Ireland and Savings(current US$) of Tonga?
Your response must be concise. 2.66e+1. In the year 2010, what is the difference between the Savings(current US$) of Saudi Arabia and Savings(current US$) of Tonga?
Your answer should be compact. 1.23e+11. What is the ratio of the Savings(current US$) of Belarus in 2004 to that in 2005?
Make the answer very short. 0.54. What is the ratio of the Savings(current US$) in Ireland in 2004 to that in 2005?
Ensure brevity in your answer.  0.93. What is the ratio of the Savings(current US$) in Saudi Arabia in 2004 to that in 2005?
Provide a short and direct response. 0.62. What is the ratio of the Savings(current US$) of Tonga in 2004 to that in 2005?
Provide a succinct answer. 2.46. What is the ratio of the Savings(current US$) of Belarus in 2004 to that in 2006?
Your answer should be very brief. 0.46. What is the ratio of the Savings(current US$) of Ireland in 2004 to that in 2006?
Provide a short and direct response. 0.89. What is the ratio of the Savings(current US$) in Saudi Arabia in 2004 to that in 2006?
Your answer should be very brief. 0.54. What is the ratio of the Savings(current US$) of Tonga in 2004 to that in 2006?
Ensure brevity in your answer.  1.37. What is the ratio of the Savings(current US$) of Belarus in 2004 to that in 2007?
Ensure brevity in your answer.  0.4. What is the ratio of the Savings(current US$) of Ireland in 2004 to that in 2007?
Provide a succinct answer. 0.9. What is the ratio of the Savings(current US$) in Saudi Arabia in 2004 to that in 2007?
Offer a very short reply. 0.48. What is the ratio of the Savings(current US$) of Tonga in 2004 to that in 2007?
Your response must be concise. 0.8. What is the ratio of the Savings(current US$) in Belarus in 2004 to that in 2008?
Keep it short and to the point. 0.28. What is the ratio of the Savings(current US$) in Ireland in 2004 to that in 2008?
Give a very brief answer. 1.11. What is the ratio of the Savings(current US$) in Saudi Arabia in 2004 to that in 2008?
Your response must be concise. 0.38. What is the ratio of the Savings(current US$) in Tonga in 2004 to that in 2008?
Keep it short and to the point. 1.36. What is the ratio of the Savings(current US$) in Belarus in 2004 to that in 2009?
Keep it short and to the point. 0.45. What is the ratio of the Savings(current US$) in Ireland in 2004 to that in 2009?
Keep it short and to the point. 1.5. What is the ratio of the Savings(current US$) of Saudi Arabia in 2004 to that in 2009?
Offer a very short reply. 0.67. What is the ratio of the Savings(current US$) in Tonga in 2004 to that in 2009?
Offer a very short reply. 1.15. What is the ratio of the Savings(current US$) in Belarus in 2004 to that in 2010?
Your answer should be very brief. 0.35. What is the ratio of the Savings(current US$) of Ireland in 2004 to that in 2010?
Your response must be concise. 1.58. What is the ratio of the Savings(current US$) of Saudi Arabia in 2004 to that in 2010?
Provide a short and direct response. 0.39. What is the ratio of the Savings(current US$) in Tonga in 2004 to that in 2010?
Provide a succinct answer. 0.77. What is the ratio of the Savings(current US$) of Belarus in 2005 to that in 2006?
Make the answer very short. 0.84. What is the ratio of the Savings(current US$) of Ireland in 2005 to that in 2006?
Provide a succinct answer. 0.96. What is the ratio of the Savings(current US$) of Saudi Arabia in 2005 to that in 2006?
Keep it short and to the point. 0.88. What is the ratio of the Savings(current US$) of Tonga in 2005 to that in 2006?
Give a very brief answer. 0.56. What is the ratio of the Savings(current US$) of Belarus in 2005 to that in 2007?
Keep it short and to the point. 0.74. What is the ratio of the Savings(current US$) in Ireland in 2005 to that in 2007?
Offer a terse response. 0.97. What is the ratio of the Savings(current US$) in Saudi Arabia in 2005 to that in 2007?
Provide a short and direct response. 0.78. What is the ratio of the Savings(current US$) of Tonga in 2005 to that in 2007?
Provide a short and direct response. 0.33. What is the ratio of the Savings(current US$) of Belarus in 2005 to that in 2008?
Offer a very short reply. 0.51. What is the ratio of the Savings(current US$) in Ireland in 2005 to that in 2008?
Your response must be concise. 1.19. What is the ratio of the Savings(current US$) of Saudi Arabia in 2005 to that in 2008?
Ensure brevity in your answer.  0.61. What is the ratio of the Savings(current US$) of Tonga in 2005 to that in 2008?
Give a very brief answer. 0.56. What is the ratio of the Savings(current US$) in Belarus in 2005 to that in 2009?
Keep it short and to the point. 0.83. What is the ratio of the Savings(current US$) in Ireland in 2005 to that in 2009?
Give a very brief answer. 1.61. What is the ratio of the Savings(current US$) of Saudi Arabia in 2005 to that in 2009?
Your answer should be very brief. 1.08. What is the ratio of the Savings(current US$) in Tonga in 2005 to that in 2009?
Offer a very short reply. 0.47. What is the ratio of the Savings(current US$) of Belarus in 2005 to that in 2010?
Your answer should be very brief. 0.65. What is the ratio of the Savings(current US$) of Ireland in 2005 to that in 2010?
Your response must be concise. 1.69. What is the ratio of the Savings(current US$) in Saudi Arabia in 2005 to that in 2010?
Give a very brief answer. 0.63. What is the ratio of the Savings(current US$) in Tonga in 2005 to that in 2010?
Provide a succinct answer. 0.31. What is the ratio of the Savings(current US$) in Belarus in 2006 to that in 2007?
Your response must be concise. 0.88. What is the ratio of the Savings(current US$) in Ireland in 2006 to that in 2007?
Provide a short and direct response. 1.01. What is the ratio of the Savings(current US$) in Saudi Arabia in 2006 to that in 2007?
Your response must be concise. 0.89. What is the ratio of the Savings(current US$) of Tonga in 2006 to that in 2007?
Offer a terse response. 0.58. What is the ratio of the Savings(current US$) in Belarus in 2006 to that in 2008?
Make the answer very short. 0.6. What is the ratio of the Savings(current US$) in Ireland in 2006 to that in 2008?
Make the answer very short. 1.24. What is the ratio of the Savings(current US$) in Saudi Arabia in 2006 to that in 2008?
Keep it short and to the point. 0.7. What is the ratio of the Savings(current US$) of Tonga in 2006 to that in 2008?
Make the answer very short. 1. What is the ratio of the Savings(current US$) in Belarus in 2006 to that in 2009?
Give a very brief answer. 0.98. What is the ratio of the Savings(current US$) of Ireland in 2006 to that in 2009?
Offer a terse response. 1.68. What is the ratio of the Savings(current US$) in Saudi Arabia in 2006 to that in 2009?
Make the answer very short. 1.24. What is the ratio of the Savings(current US$) of Tonga in 2006 to that in 2009?
Your answer should be compact. 0.84. What is the ratio of the Savings(current US$) in Belarus in 2006 to that in 2010?
Ensure brevity in your answer.  0.77. What is the ratio of the Savings(current US$) of Ireland in 2006 to that in 2010?
Your answer should be compact. 1.77. What is the ratio of the Savings(current US$) in Saudi Arabia in 2006 to that in 2010?
Your answer should be very brief. 0.71. What is the ratio of the Savings(current US$) in Tonga in 2006 to that in 2010?
Your answer should be very brief. 0.56. What is the ratio of the Savings(current US$) of Belarus in 2007 to that in 2008?
Provide a short and direct response. 0.69. What is the ratio of the Savings(current US$) in Ireland in 2007 to that in 2008?
Provide a succinct answer. 1.23. What is the ratio of the Savings(current US$) in Saudi Arabia in 2007 to that in 2008?
Your answer should be compact. 0.78. What is the ratio of the Savings(current US$) in Tonga in 2007 to that in 2008?
Your answer should be compact. 1.7. What is the ratio of the Savings(current US$) of Belarus in 2007 to that in 2009?
Keep it short and to the point. 1.12. What is the ratio of the Savings(current US$) of Ireland in 2007 to that in 2009?
Provide a succinct answer. 1.67. What is the ratio of the Savings(current US$) of Saudi Arabia in 2007 to that in 2009?
Your answer should be very brief. 1.39. What is the ratio of the Savings(current US$) of Tonga in 2007 to that in 2009?
Offer a terse response. 1.43. What is the ratio of the Savings(current US$) of Belarus in 2007 to that in 2010?
Ensure brevity in your answer.  0.88. What is the ratio of the Savings(current US$) in Ireland in 2007 to that in 2010?
Keep it short and to the point. 1.75. What is the ratio of the Savings(current US$) in Saudi Arabia in 2007 to that in 2010?
Offer a very short reply. 0.8. What is the ratio of the Savings(current US$) of Tonga in 2007 to that in 2010?
Provide a succinct answer. 0.96. What is the ratio of the Savings(current US$) in Belarus in 2008 to that in 2009?
Provide a short and direct response. 1.62. What is the ratio of the Savings(current US$) in Ireland in 2008 to that in 2009?
Your answer should be very brief. 1.36. What is the ratio of the Savings(current US$) in Saudi Arabia in 2008 to that in 2009?
Ensure brevity in your answer.  1.77. What is the ratio of the Savings(current US$) in Tonga in 2008 to that in 2009?
Provide a succinct answer. 0.84. What is the ratio of the Savings(current US$) in Belarus in 2008 to that in 2010?
Your answer should be very brief. 1.28. What is the ratio of the Savings(current US$) in Ireland in 2008 to that in 2010?
Provide a succinct answer. 1.42. What is the ratio of the Savings(current US$) in Saudi Arabia in 2008 to that in 2010?
Keep it short and to the point. 1.02. What is the ratio of the Savings(current US$) in Tonga in 2008 to that in 2010?
Ensure brevity in your answer.  0.57. What is the ratio of the Savings(current US$) of Belarus in 2009 to that in 2010?
Offer a terse response. 0.79. What is the ratio of the Savings(current US$) of Ireland in 2009 to that in 2010?
Offer a very short reply. 1.05. What is the ratio of the Savings(current US$) of Saudi Arabia in 2009 to that in 2010?
Offer a very short reply. 0.58. What is the ratio of the Savings(current US$) of Tonga in 2009 to that in 2010?
Offer a terse response. 0.67. What is the difference between the highest and the second highest Savings(current US$) in Belarus?
Your response must be concise. 3.05e+09. What is the difference between the highest and the second highest Savings(current US$) in Ireland?
Your answer should be very brief. 4.67e+08. What is the difference between the highest and the second highest Savings(current US$) in Saudi Arabia?
Make the answer very short. 3.06e+09. What is the difference between the highest and the second highest Savings(current US$) in Tonga?
Give a very brief answer. 1.69e+06. What is the difference between the highest and the lowest Savings(current US$) of Belarus?
Your answer should be compact. 1.01e+1. What is the difference between the highest and the lowest Savings(current US$) in Ireland?
Give a very brief answer. 2.05e+1. What is the difference between the highest and the lowest Savings(current US$) of Saudi Arabia?
Keep it short and to the point. 7.86e+1. What is the difference between the highest and the lowest Savings(current US$) in Tonga?
Make the answer very short. 3.14e+07. 